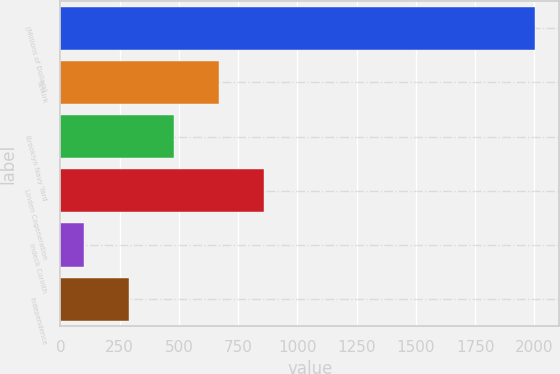Convert chart to OTSL. <chart><loc_0><loc_0><loc_500><loc_500><bar_chart><fcel>(Millions of Dollars)<fcel>Selkirk<fcel>Brooklyn Navy Yard<fcel>Linden Cogeneration<fcel>Indeck Corinth<fcel>Independence<nl><fcel>2004<fcel>670.5<fcel>480<fcel>861<fcel>99<fcel>289.5<nl></chart> 